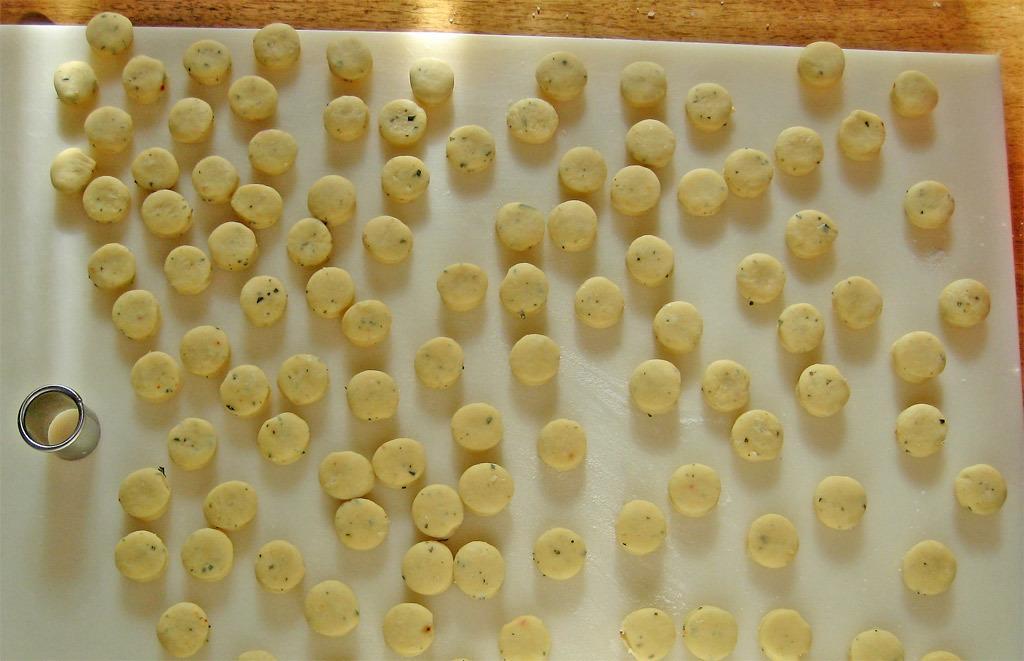Can you describe this image briefly? This image consists of food which is on the surface which is white in colour and there is a glass. 